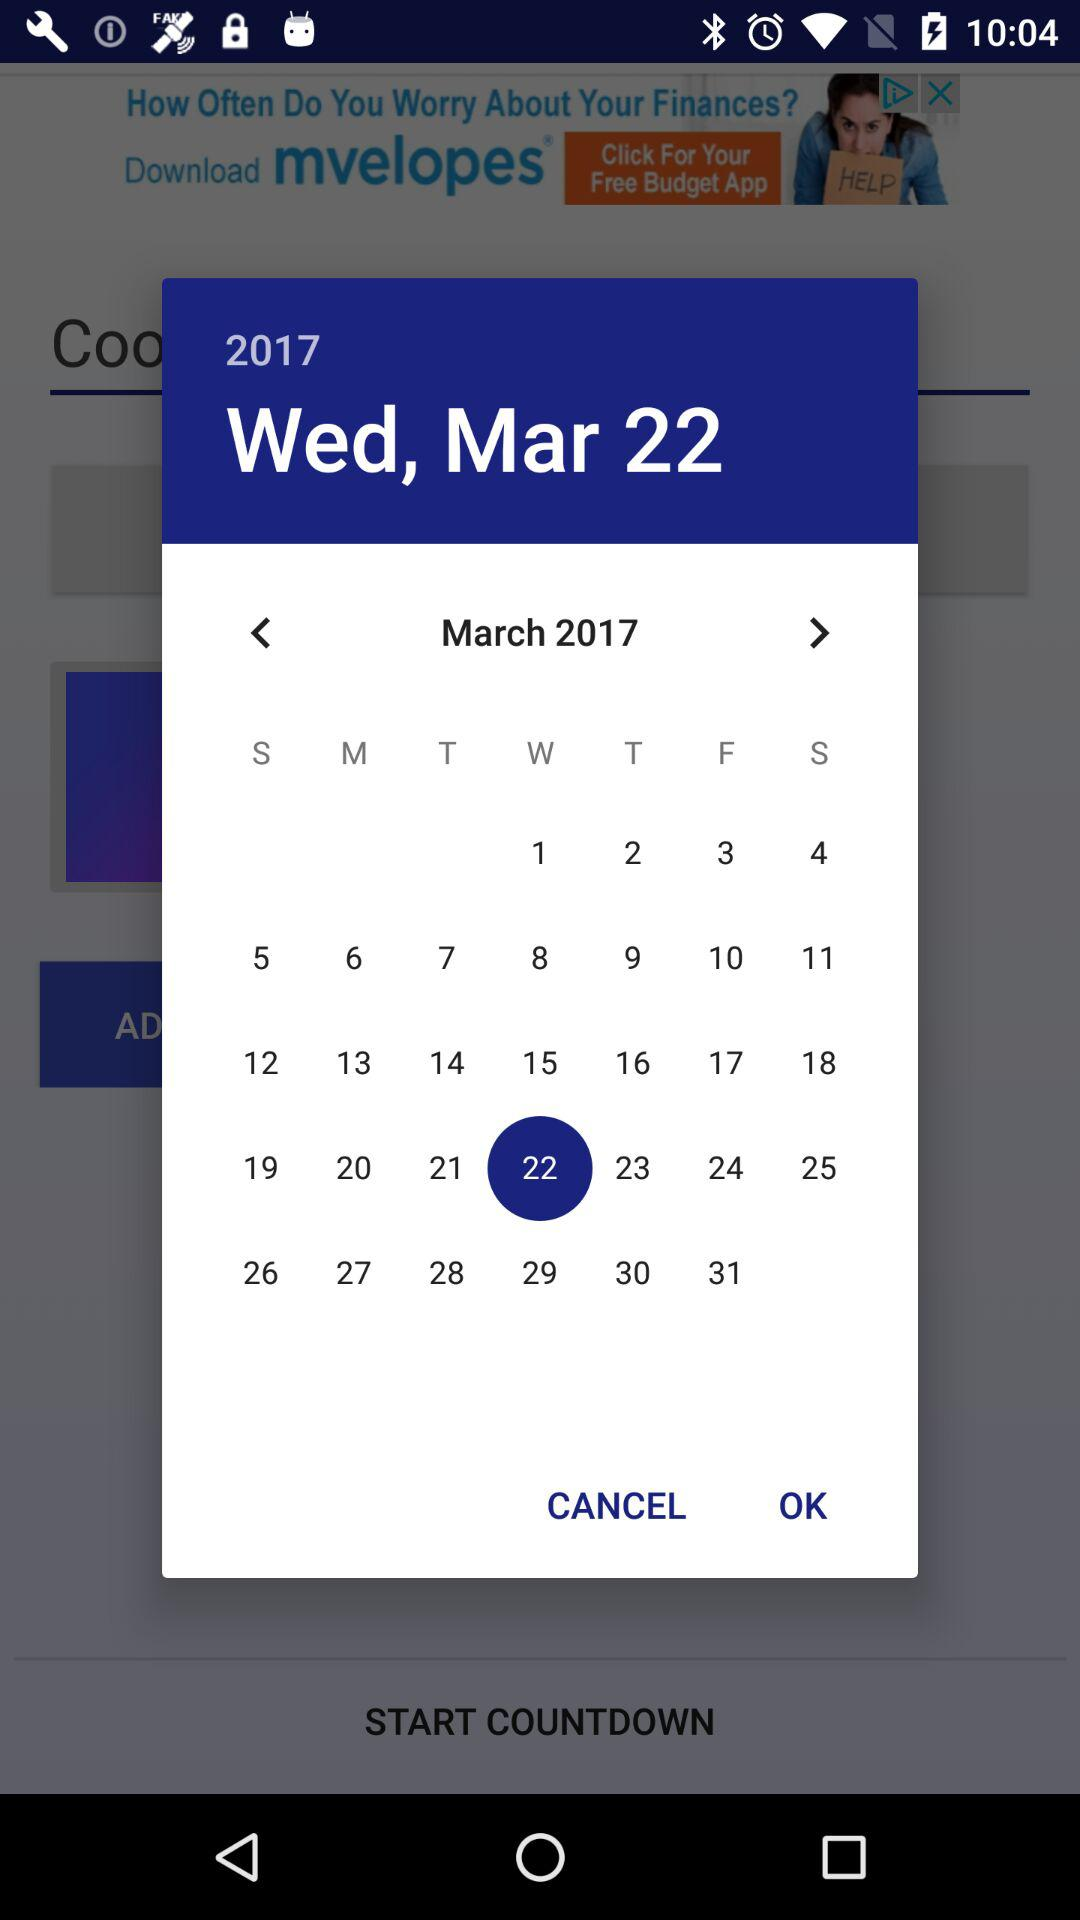What is the selected date? The selected date is Wednesday, March 22, 2017. 